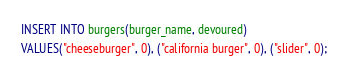Convert code to text. <code><loc_0><loc_0><loc_500><loc_500><_SQL_>INSERT INTO burgers(burger_name, devoured)
VALUES("cheeseburger", 0), ("california burger", 0), ("slider", 0);</code> 